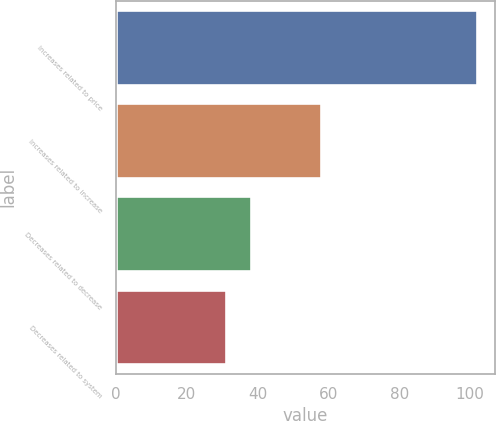Convert chart. <chart><loc_0><loc_0><loc_500><loc_500><bar_chart><fcel>Increases related to price<fcel>Increases related to increase<fcel>Decreases related to decrease<fcel>Decreases related to system<nl><fcel>102<fcel>58<fcel>38.1<fcel>31<nl></chart> 